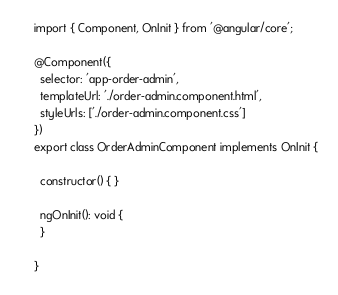Convert code to text. <code><loc_0><loc_0><loc_500><loc_500><_TypeScript_>import { Component, OnInit } from '@angular/core';

@Component({
  selector: 'app-order-admin',
  templateUrl: './order-admin.component.html',
  styleUrls: ['./order-admin.component.css']
})
export class OrderAdminComponent implements OnInit {

  constructor() { }

  ngOnInit(): void {
  }

}
</code> 